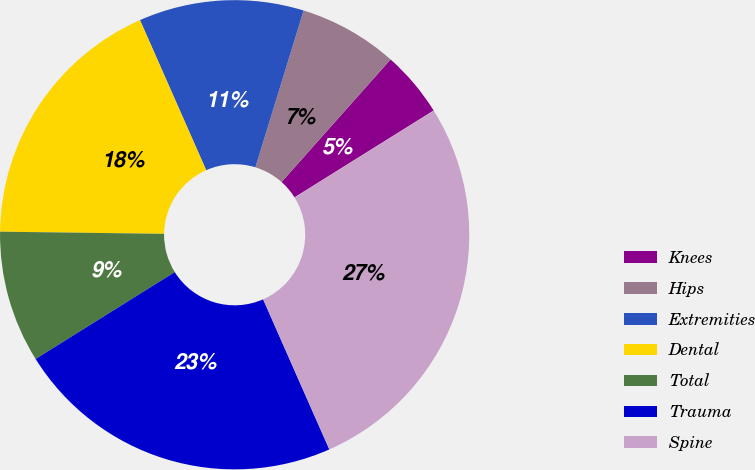Convert chart to OTSL. <chart><loc_0><loc_0><loc_500><loc_500><pie_chart><fcel>Knees<fcel>Hips<fcel>Extremities<fcel>Dental<fcel>Total<fcel>Trauma<fcel>Spine<nl><fcel>4.55%<fcel>6.82%<fcel>11.36%<fcel>18.18%<fcel>9.09%<fcel>22.73%<fcel>27.27%<nl></chart> 